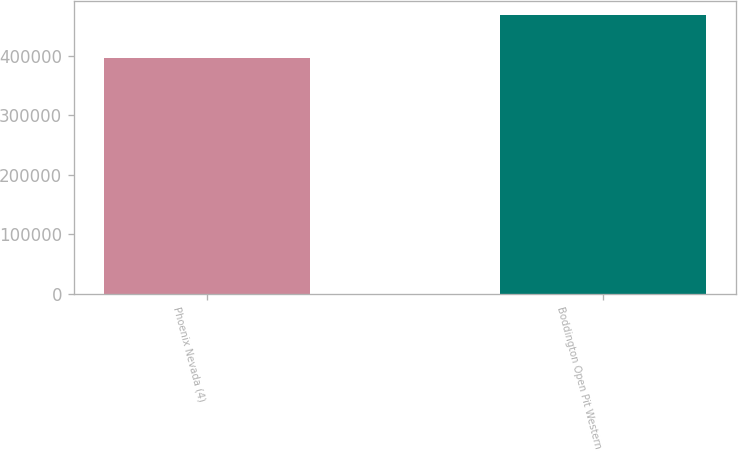Convert chart to OTSL. <chart><loc_0><loc_0><loc_500><loc_500><bar_chart><fcel>Phoenix Nevada (4)<fcel>Boddington Open Pit Western<nl><fcel>395500<fcel>467600<nl></chart> 